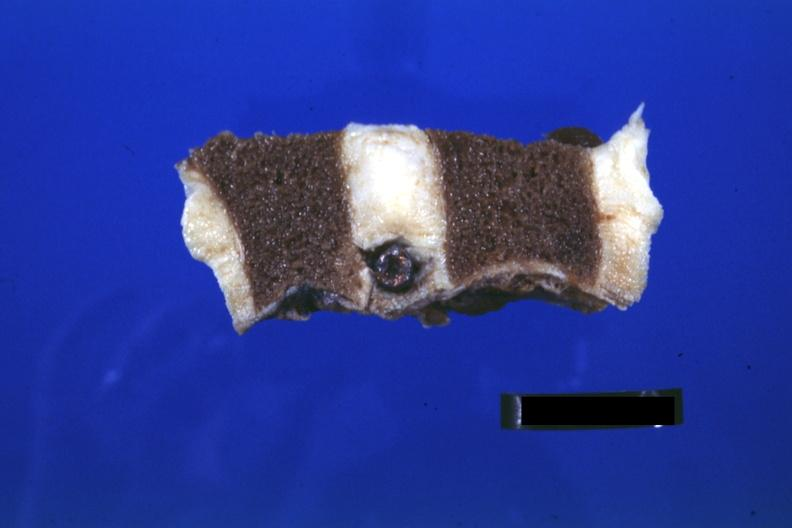s hours present?
Answer the question using a single word or phrase. No 